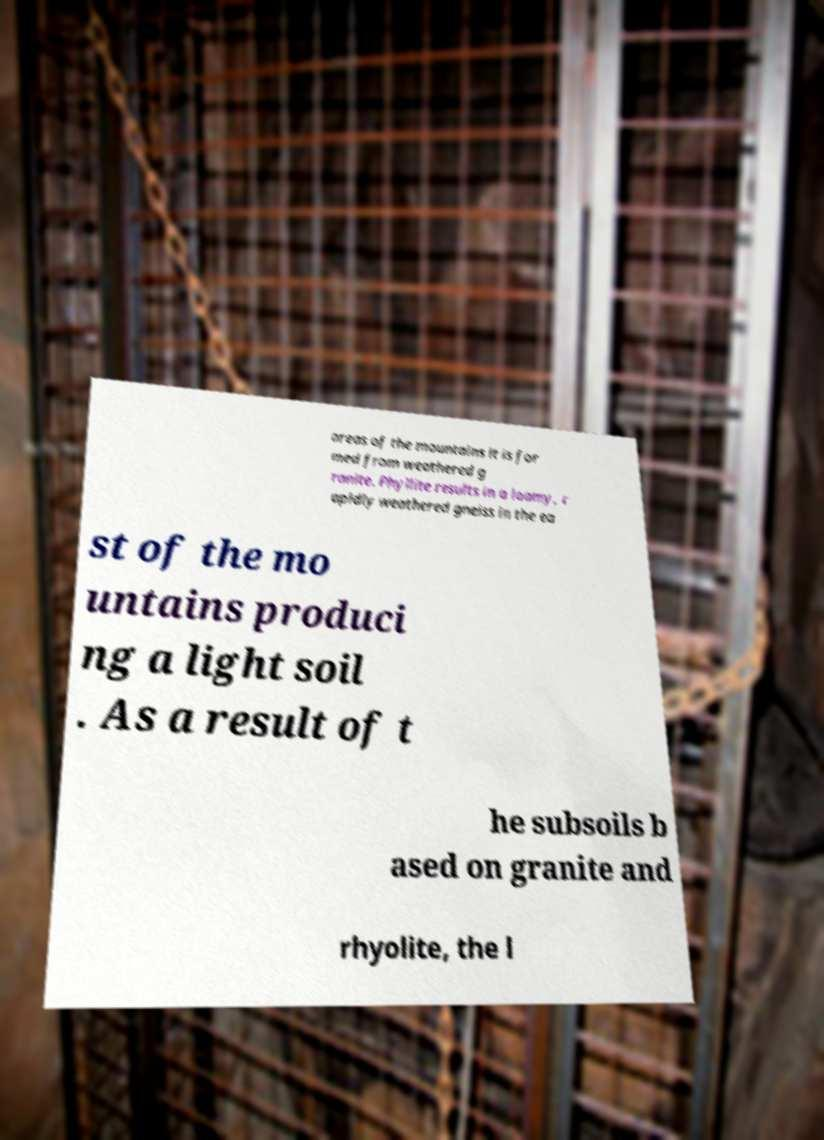I need the written content from this picture converted into text. Can you do that? areas of the mountains it is for med from weathered g ranite. Phyllite results in a loamy, r apidly weathered gneiss in the ea st of the mo untains produci ng a light soil . As a result of t he subsoils b ased on granite and rhyolite, the l 